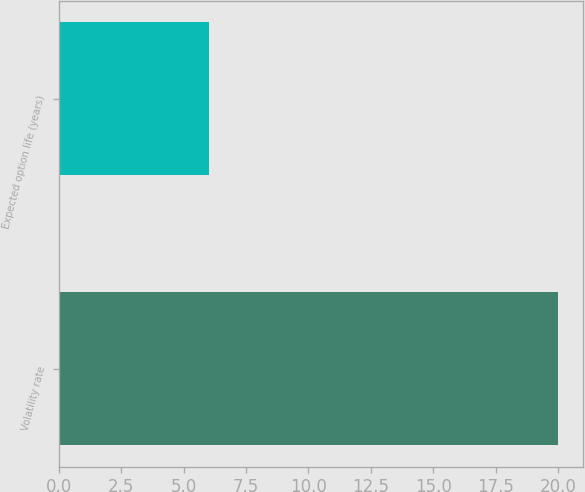Convert chart to OTSL. <chart><loc_0><loc_0><loc_500><loc_500><bar_chart><fcel>Volatility rate<fcel>Expected option life (years)<nl><fcel>20<fcel>6<nl></chart> 